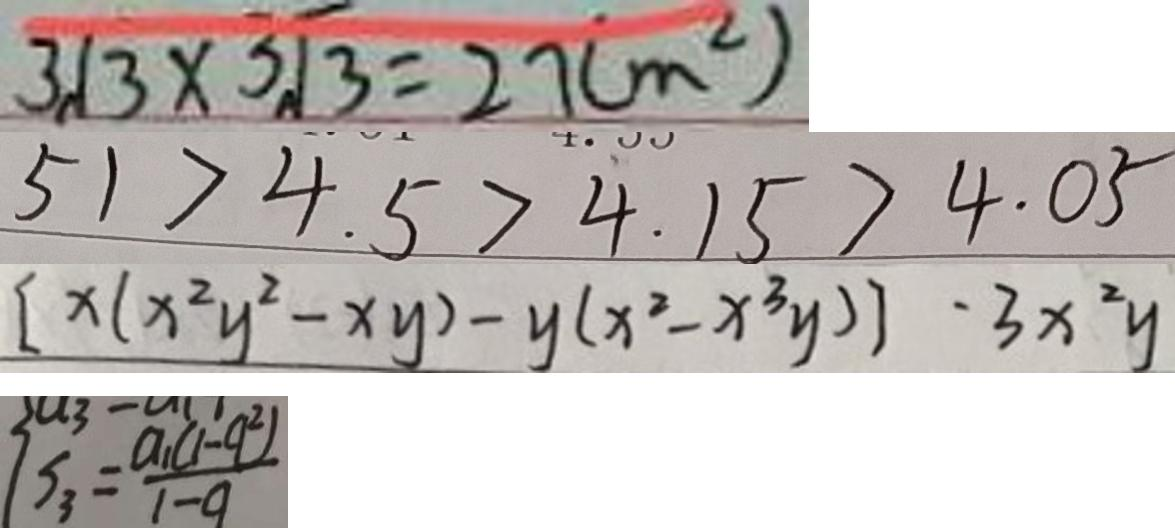Convert formula to latex. <formula><loc_0><loc_0><loc_500><loc_500>3 \sqrt { 3 } \times 3 \sqrt { 3 } = 2 7 ( m ^ { 2 } ) 
 5 1 > 4 . 5 > 4 . 1 5 > 4 . 0 5 
 [ x ( x ^ { 2 } y ^ { 2 } - x y ) - y ( x ^ { 3 } - x ^ { 3 } y ) ] \cdot 3 x ^ { 2 } y 
 S _ { 3 } = \frac { a _ { 1 } ( 1 - q ^ { 2 } ) } { 1 - q }</formula> 